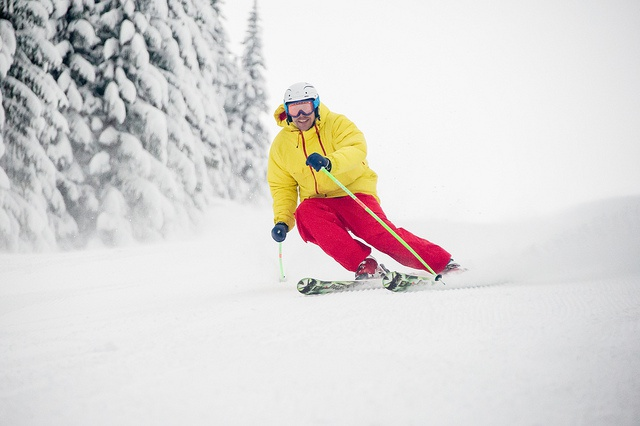Describe the objects in this image and their specific colors. I can see people in gray, khaki, brown, and lightgray tones and skis in gray, lightgray, darkgray, and beige tones in this image. 